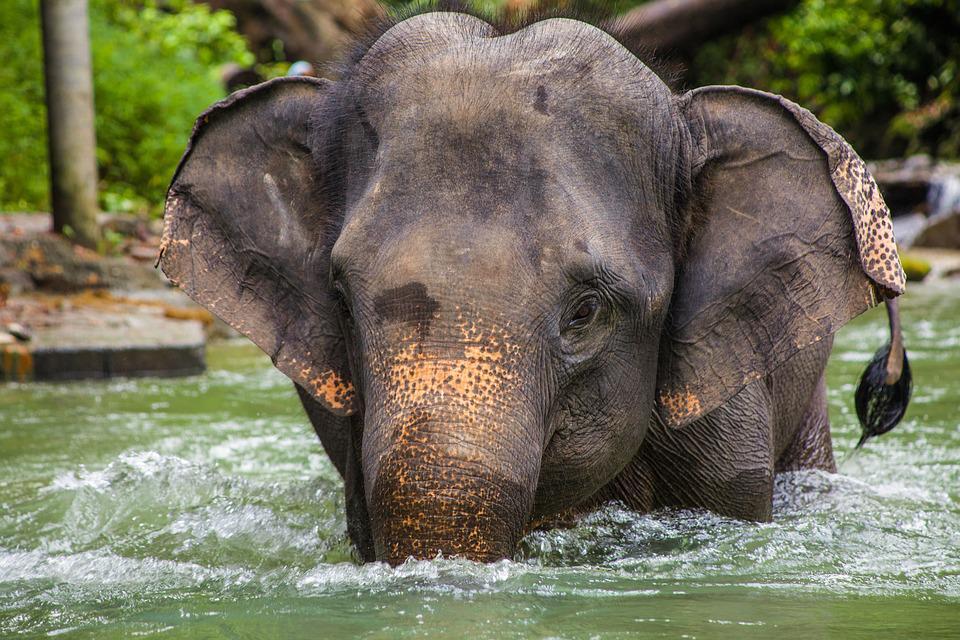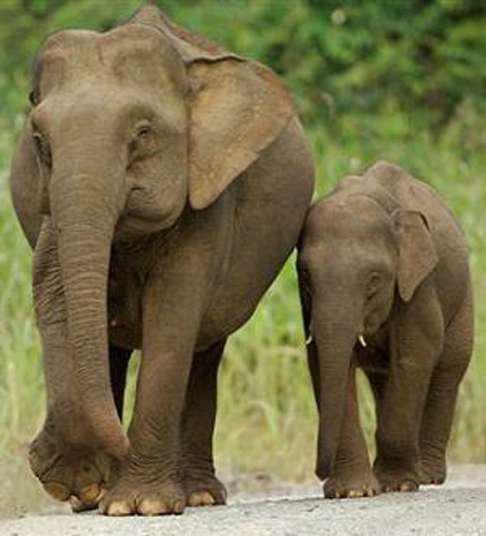The first image is the image on the left, the second image is the image on the right. Assess this claim about the two images: "Every image shows exactly one elephant that is outdoors.". Correct or not? Answer yes or no. No. The first image is the image on the left, the second image is the image on the right. Evaluate the accuracy of this statement regarding the images: "An image shows a young elephant standing next to at least one adult elephant.". Is it true? Answer yes or no. Yes. The first image is the image on the left, the second image is the image on the right. Considering the images on both sides, is "An enclosure is seen behind one of the elephants." valid? Answer yes or no. No. The first image is the image on the left, the second image is the image on the right. For the images displayed, is the sentence "There is at least two elephants in the right image." factually correct? Answer yes or no. Yes. 